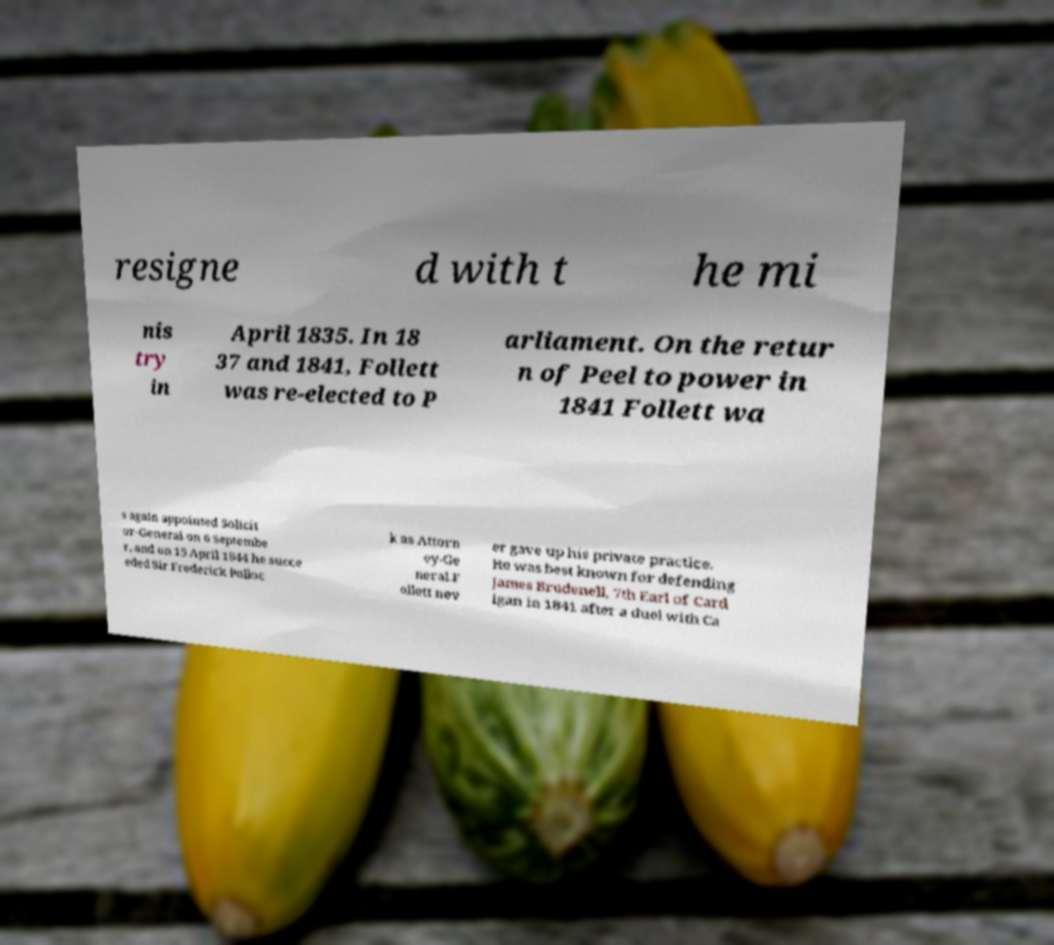What messages or text are displayed in this image? I need them in a readable, typed format. resigne d with t he mi nis try in April 1835. In 18 37 and 1841, Follett was re-elected to P arliament. On the retur n of Peel to power in 1841 Follett wa s again appointed Solicit or-General on 6 Septembe r, and on 15 April 1844 he succe eded Sir Frederick Polloc k as Attorn ey-Ge neral.F ollett nev er gave up his private practice. He was best known for defending James Brudenell, 7th Earl of Card igan in 1841 after a duel with Ca 